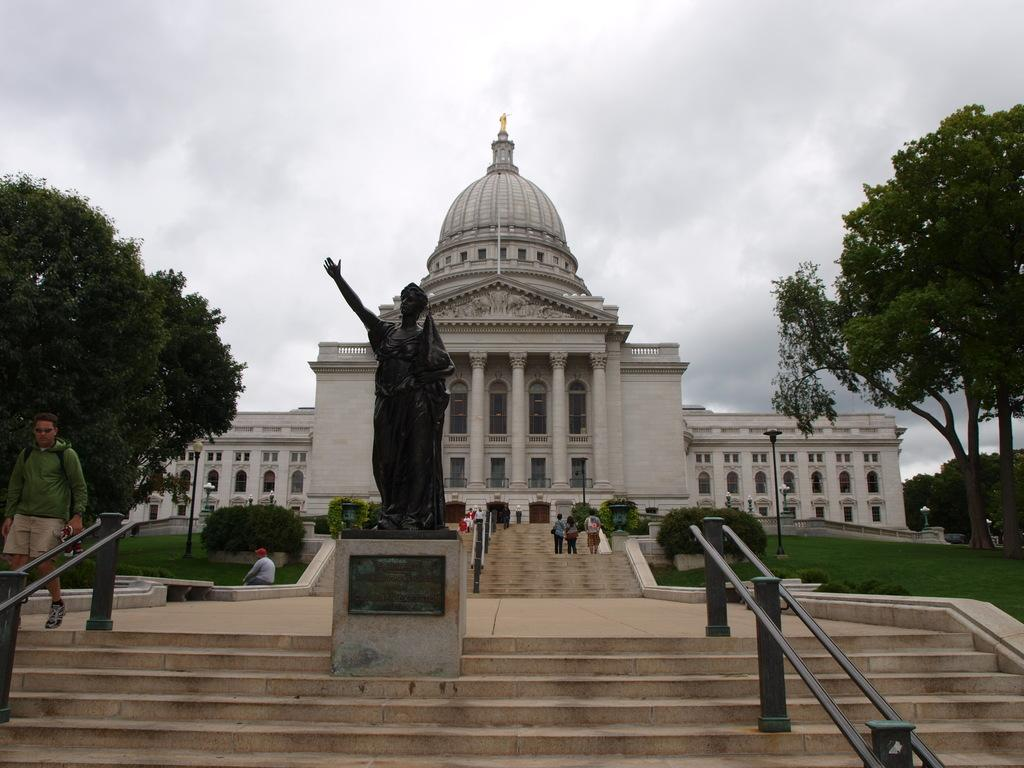What type of structure is present in the image? There is a building in the image. What other object can be seen near the building? There is a statue in the image. What type of vegetation is present in the image? There are trees in the image. What architectural feature is present in the image? There are stairs in the image. What is visible in the background of the image? The sky is visible in the image. What type of juice is being served at the event depicted in the image? There is no event or juice present in the image; it features a building, statue, trees, stairs, and the sky. What suggestion is being made by the person in the image? There is no person or suggestion present in the image. 